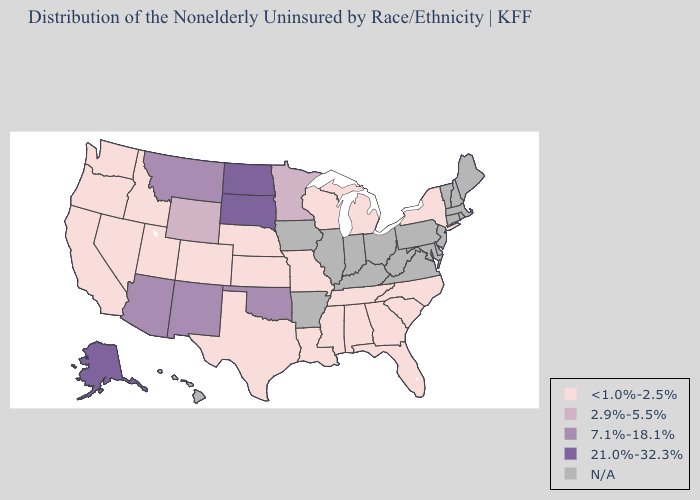Which states have the lowest value in the USA?
Keep it brief. Alabama, California, Colorado, Florida, Georgia, Idaho, Kansas, Louisiana, Michigan, Mississippi, Missouri, Nebraska, Nevada, New York, North Carolina, Oregon, South Carolina, Tennessee, Texas, Utah, Washington, Wisconsin. What is the lowest value in the USA?
Short answer required. <1.0%-2.5%. Name the states that have a value in the range N/A?
Concise answer only. Arkansas, Connecticut, Delaware, Hawaii, Illinois, Indiana, Iowa, Kentucky, Maine, Maryland, Massachusetts, New Hampshire, New Jersey, Ohio, Pennsylvania, Rhode Island, Vermont, Virginia, West Virginia. Name the states that have a value in the range 7.1%-18.1%?
Be succinct. Arizona, Montana, New Mexico, Oklahoma. What is the lowest value in the USA?
Write a very short answer. <1.0%-2.5%. Name the states that have a value in the range 7.1%-18.1%?
Concise answer only. Arizona, Montana, New Mexico, Oklahoma. Among the states that border Iowa , which have the highest value?
Write a very short answer. South Dakota. Does the first symbol in the legend represent the smallest category?
Write a very short answer. Yes. Is the legend a continuous bar?
Give a very brief answer. No. What is the lowest value in the MidWest?
Concise answer only. <1.0%-2.5%. 